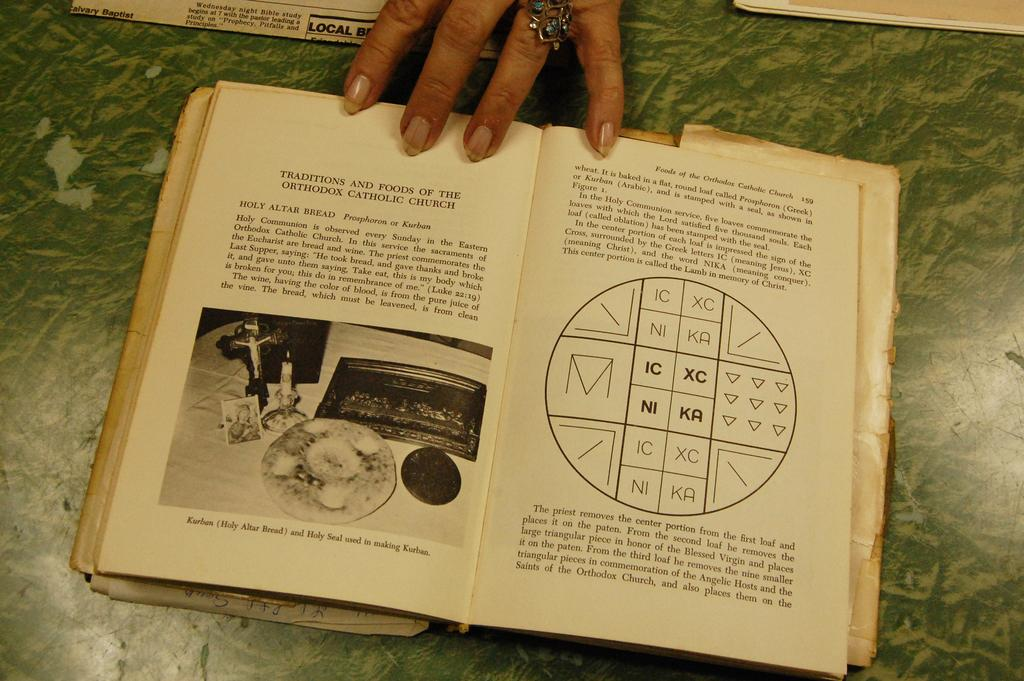<image>
Create a compact narrative representing the image presented. a book that says kurban on the bottom of it 